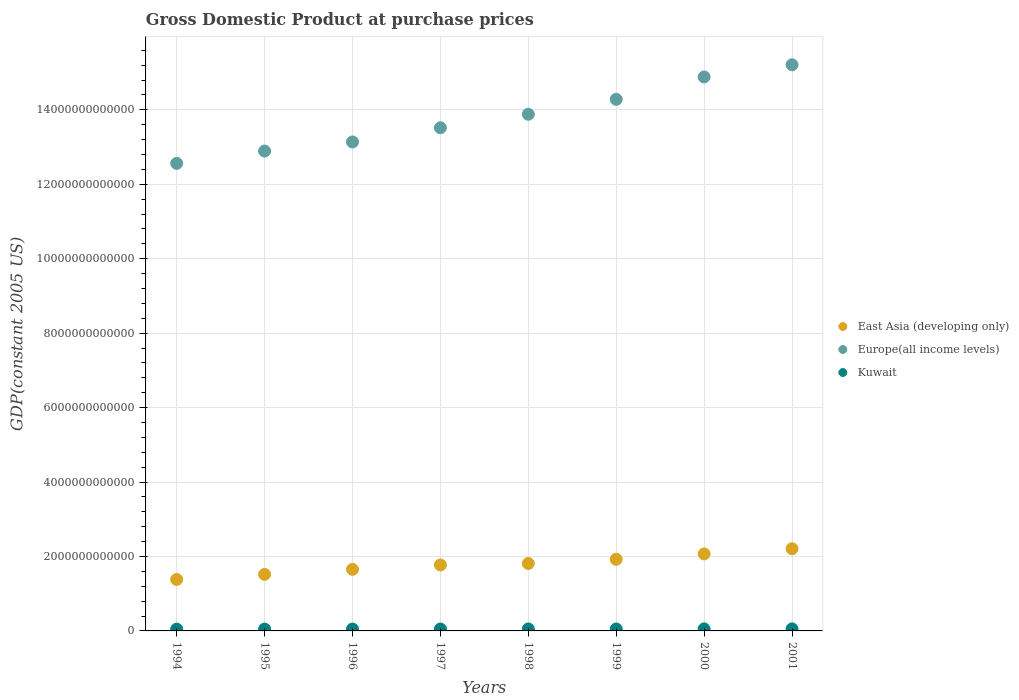What is the GDP at purchase prices in East Asia (developing only) in 2001?
Ensure brevity in your answer.  2.21e+12. Across all years, what is the maximum GDP at purchase prices in East Asia (developing only)?
Keep it short and to the point. 2.21e+12. Across all years, what is the minimum GDP at purchase prices in Kuwait?
Provide a succinct answer. 4.73e+1. In which year was the GDP at purchase prices in Kuwait maximum?
Ensure brevity in your answer.  2001. What is the total GDP at purchase prices in Kuwait in the graph?
Give a very brief answer. 4.12e+11. What is the difference between the GDP at purchase prices in East Asia (developing only) in 1994 and that in 1995?
Offer a very short reply. -1.36e+11. What is the difference between the GDP at purchase prices in East Asia (developing only) in 2000 and the GDP at purchase prices in Kuwait in 1996?
Your response must be concise. 2.02e+12. What is the average GDP at purchase prices in Kuwait per year?
Your response must be concise. 5.15e+1. In the year 1995, what is the difference between the GDP at purchase prices in Kuwait and GDP at purchase prices in Europe(all income levels)?
Offer a terse response. -1.28e+13. What is the ratio of the GDP at purchase prices in Kuwait in 1995 to that in 2001?
Offer a very short reply. 0.9. Is the GDP at purchase prices in Kuwait in 1996 less than that in 2000?
Provide a short and direct response. Yes. What is the difference between the highest and the second highest GDP at purchase prices in Europe(all income levels)?
Keep it short and to the point. 3.26e+11. What is the difference between the highest and the lowest GDP at purchase prices in Kuwait?
Ensure brevity in your answer.  7.59e+09. In how many years, is the GDP at purchase prices in Kuwait greater than the average GDP at purchase prices in Kuwait taken over all years?
Provide a succinct answer. 4. Is the sum of the GDP at purchase prices in Kuwait in 1994 and 1998 greater than the maximum GDP at purchase prices in East Asia (developing only) across all years?
Your answer should be compact. No. Is it the case that in every year, the sum of the GDP at purchase prices in Kuwait and GDP at purchase prices in East Asia (developing only)  is greater than the GDP at purchase prices in Europe(all income levels)?
Make the answer very short. No. Does the GDP at purchase prices in East Asia (developing only) monotonically increase over the years?
Provide a succinct answer. Yes. Is the GDP at purchase prices in Europe(all income levels) strictly less than the GDP at purchase prices in East Asia (developing only) over the years?
Provide a succinct answer. No. How many dotlines are there?
Your answer should be compact. 3. What is the difference between two consecutive major ticks on the Y-axis?
Make the answer very short. 2.00e+12. Are the values on the major ticks of Y-axis written in scientific E-notation?
Offer a terse response. No. Where does the legend appear in the graph?
Your answer should be compact. Center right. How many legend labels are there?
Ensure brevity in your answer.  3. How are the legend labels stacked?
Your answer should be compact. Vertical. What is the title of the graph?
Offer a very short reply. Gross Domestic Product at purchase prices. What is the label or title of the Y-axis?
Provide a short and direct response. GDP(constant 2005 US). What is the GDP(constant 2005 US) in East Asia (developing only) in 1994?
Make the answer very short. 1.38e+12. What is the GDP(constant 2005 US) in Europe(all income levels) in 1994?
Your answer should be very brief. 1.26e+13. What is the GDP(constant 2005 US) of Kuwait in 1994?
Your answer should be compact. 4.73e+1. What is the GDP(constant 2005 US) in East Asia (developing only) in 1995?
Make the answer very short. 1.52e+12. What is the GDP(constant 2005 US) in Europe(all income levels) in 1995?
Provide a short and direct response. 1.29e+13. What is the GDP(constant 2005 US) in Kuwait in 1995?
Offer a very short reply. 4.95e+1. What is the GDP(constant 2005 US) in East Asia (developing only) in 1996?
Your response must be concise. 1.65e+12. What is the GDP(constant 2005 US) in Europe(all income levels) in 1996?
Your answer should be compact. 1.31e+13. What is the GDP(constant 2005 US) of Kuwait in 1996?
Your answer should be compact. 4.98e+1. What is the GDP(constant 2005 US) of East Asia (developing only) in 1997?
Provide a succinct answer. 1.77e+12. What is the GDP(constant 2005 US) of Europe(all income levels) in 1997?
Keep it short and to the point. 1.35e+13. What is the GDP(constant 2005 US) of Kuwait in 1997?
Ensure brevity in your answer.  5.11e+1. What is the GDP(constant 2005 US) in East Asia (developing only) in 1998?
Offer a very short reply. 1.81e+12. What is the GDP(constant 2005 US) in Europe(all income levels) in 1998?
Offer a very short reply. 1.39e+13. What is the GDP(constant 2005 US) of Kuwait in 1998?
Keep it short and to the point. 5.30e+1. What is the GDP(constant 2005 US) of East Asia (developing only) in 1999?
Your response must be concise. 1.92e+12. What is the GDP(constant 2005 US) in Europe(all income levels) in 1999?
Keep it short and to the point. 1.43e+13. What is the GDP(constant 2005 US) of Kuwait in 1999?
Offer a very short reply. 5.20e+1. What is the GDP(constant 2005 US) of East Asia (developing only) in 2000?
Provide a short and direct response. 2.07e+12. What is the GDP(constant 2005 US) of Europe(all income levels) in 2000?
Provide a succinct answer. 1.49e+13. What is the GDP(constant 2005 US) in Kuwait in 2000?
Provide a short and direct response. 5.44e+1. What is the GDP(constant 2005 US) of East Asia (developing only) in 2001?
Offer a terse response. 2.21e+12. What is the GDP(constant 2005 US) in Europe(all income levels) in 2001?
Give a very brief answer. 1.52e+13. What is the GDP(constant 2005 US) of Kuwait in 2001?
Offer a very short reply. 5.48e+1. Across all years, what is the maximum GDP(constant 2005 US) in East Asia (developing only)?
Keep it short and to the point. 2.21e+12. Across all years, what is the maximum GDP(constant 2005 US) of Europe(all income levels)?
Ensure brevity in your answer.  1.52e+13. Across all years, what is the maximum GDP(constant 2005 US) of Kuwait?
Provide a succinct answer. 5.48e+1. Across all years, what is the minimum GDP(constant 2005 US) in East Asia (developing only)?
Keep it short and to the point. 1.38e+12. Across all years, what is the minimum GDP(constant 2005 US) of Europe(all income levels)?
Offer a very short reply. 1.26e+13. Across all years, what is the minimum GDP(constant 2005 US) in Kuwait?
Make the answer very short. 4.73e+1. What is the total GDP(constant 2005 US) in East Asia (developing only) in the graph?
Keep it short and to the point. 1.43e+13. What is the total GDP(constant 2005 US) in Europe(all income levels) in the graph?
Give a very brief answer. 1.10e+14. What is the total GDP(constant 2005 US) of Kuwait in the graph?
Make the answer very short. 4.12e+11. What is the difference between the GDP(constant 2005 US) of East Asia (developing only) in 1994 and that in 1995?
Make the answer very short. -1.36e+11. What is the difference between the GDP(constant 2005 US) of Europe(all income levels) in 1994 and that in 1995?
Offer a very short reply. -3.31e+11. What is the difference between the GDP(constant 2005 US) of Kuwait in 1994 and that in 1995?
Provide a short and direct response. -2.30e+09. What is the difference between the GDP(constant 2005 US) in East Asia (developing only) in 1994 and that in 1996?
Give a very brief answer. -2.72e+11. What is the difference between the GDP(constant 2005 US) of Europe(all income levels) in 1994 and that in 1996?
Ensure brevity in your answer.  -5.76e+11. What is the difference between the GDP(constant 2005 US) of Kuwait in 1994 and that in 1996?
Ensure brevity in your answer.  -2.60e+09. What is the difference between the GDP(constant 2005 US) of East Asia (developing only) in 1994 and that in 1997?
Give a very brief answer. -3.90e+11. What is the difference between the GDP(constant 2005 US) in Europe(all income levels) in 1994 and that in 1997?
Offer a very short reply. -9.57e+11. What is the difference between the GDP(constant 2005 US) in Kuwait in 1994 and that in 1997?
Your answer should be compact. -3.83e+09. What is the difference between the GDP(constant 2005 US) of East Asia (developing only) in 1994 and that in 1998?
Your response must be concise. -4.29e+11. What is the difference between the GDP(constant 2005 US) of Europe(all income levels) in 1994 and that in 1998?
Provide a succinct answer. -1.32e+12. What is the difference between the GDP(constant 2005 US) of Kuwait in 1994 and that in 1998?
Your answer should be compact. -5.70e+09. What is the difference between the GDP(constant 2005 US) in East Asia (developing only) in 1994 and that in 1999?
Provide a succinct answer. -5.42e+11. What is the difference between the GDP(constant 2005 US) in Europe(all income levels) in 1994 and that in 1999?
Make the answer very short. -1.72e+12. What is the difference between the GDP(constant 2005 US) in Kuwait in 1994 and that in 1999?
Make the answer very short. -4.75e+09. What is the difference between the GDP(constant 2005 US) in East Asia (developing only) in 1994 and that in 2000?
Provide a succinct answer. -6.87e+11. What is the difference between the GDP(constant 2005 US) of Europe(all income levels) in 1994 and that in 2000?
Offer a terse response. -2.32e+12. What is the difference between the GDP(constant 2005 US) in Kuwait in 1994 and that in 2000?
Make the answer very short. -7.19e+09. What is the difference between the GDP(constant 2005 US) in East Asia (developing only) in 1994 and that in 2001?
Provide a short and direct response. -8.25e+11. What is the difference between the GDP(constant 2005 US) in Europe(all income levels) in 1994 and that in 2001?
Offer a terse response. -2.65e+12. What is the difference between the GDP(constant 2005 US) in Kuwait in 1994 and that in 2001?
Make the answer very short. -7.59e+09. What is the difference between the GDP(constant 2005 US) of East Asia (developing only) in 1995 and that in 1996?
Your answer should be very brief. -1.36e+11. What is the difference between the GDP(constant 2005 US) of Europe(all income levels) in 1995 and that in 1996?
Make the answer very short. -2.45e+11. What is the difference between the GDP(constant 2005 US) in Kuwait in 1995 and that in 1996?
Offer a terse response. -3.00e+08. What is the difference between the GDP(constant 2005 US) in East Asia (developing only) in 1995 and that in 1997?
Ensure brevity in your answer.  -2.53e+11. What is the difference between the GDP(constant 2005 US) of Europe(all income levels) in 1995 and that in 1997?
Your answer should be very brief. -6.26e+11. What is the difference between the GDP(constant 2005 US) of Kuwait in 1995 and that in 1997?
Make the answer very short. -1.53e+09. What is the difference between the GDP(constant 2005 US) in East Asia (developing only) in 1995 and that in 1998?
Keep it short and to the point. -2.93e+11. What is the difference between the GDP(constant 2005 US) of Europe(all income levels) in 1995 and that in 1998?
Your answer should be very brief. -9.89e+11. What is the difference between the GDP(constant 2005 US) in Kuwait in 1995 and that in 1998?
Give a very brief answer. -3.40e+09. What is the difference between the GDP(constant 2005 US) of East Asia (developing only) in 1995 and that in 1999?
Your answer should be very brief. -4.06e+11. What is the difference between the GDP(constant 2005 US) in Europe(all income levels) in 1995 and that in 1999?
Make the answer very short. -1.39e+12. What is the difference between the GDP(constant 2005 US) of Kuwait in 1995 and that in 1999?
Your response must be concise. -2.46e+09. What is the difference between the GDP(constant 2005 US) in East Asia (developing only) in 1995 and that in 2000?
Provide a short and direct response. -5.50e+11. What is the difference between the GDP(constant 2005 US) in Europe(all income levels) in 1995 and that in 2000?
Your response must be concise. -1.99e+12. What is the difference between the GDP(constant 2005 US) of Kuwait in 1995 and that in 2000?
Provide a short and direct response. -4.90e+09. What is the difference between the GDP(constant 2005 US) in East Asia (developing only) in 1995 and that in 2001?
Provide a succinct answer. -6.89e+11. What is the difference between the GDP(constant 2005 US) in Europe(all income levels) in 1995 and that in 2001?
Give a very brief answer. -2.32e+12. What is the difference between the GDP(constant 2005 US) of Kuwait in 1995 and that in 2001?
Keep it short and to the point. -5.29e+09. What is the difference between the GDP(constant 2005 US) of East Asia (developing only) in 1996 and that in 1997?
Your response must be concise. -1.17e+11. What is the difference between the GDP(constant 2005 US) of Europe(all income levels) in 1996 and that in 1997?
Offer a terse response. -3.81e+11. What is the difference between the GDP(constant 2005 US) in Kuwait in 1996 and that in 1997?
Your response must be concise. -1.23e+09. What is the difference between the GDP(constant 2005 US) of East Asia (developing only) in 1996 and that in 1998?
Give a very brief answer. -1.57e+11. What is the difference between the GDP(constant 2005 US) in Europe(all income levels) in 1996 and that in 1998?
Your answer should be compact. -7.44e+11. What is the difference between the GDP(constant 2005 US) in Kuwait in 1996 and that in 1998?
Give a very brief answer. -3.10e+09. What is the difference between the GDP(constant 2005 US) of East Asia (developing only) in 1996 and that in 1999?
Make the answer very short. -2.70e+11. What is the difference between the GDP(constant 2005 US) of Europe(all income levels) in 1996 and that in 1999?
Provide a succinct answer. -1.15e+12. What is the difference between the GDP(constant 2005 US) in Kuwait in 1996 and that in 1999?
Provide a succinct answer. -2.16e+09. What is the difference between the GDP(constant 2005 US) in East Asia (developing only) in 1996 and that in 2000?
Offer a terse response. -4.14e+11. What is the difference between the GDP(constant 2005 US) of Europe(all income levels) in 1996 and that in 2000?
Your response must be concise. -1.75e+12. What is the difference between the GDP(constant 2005 US) of Kuwait in 1996 and that in 2000?
Offer a very short reply. -4.60e+09. What is the difference between the GDP(constant 2005 US) in East Asia (developing only) in 1996 and that in 2001?
Ensure brevity in your answer.  -5.53e+11. What is the difference between the GDP(constant 2005 US) in Europe(all income levels) in 1996 and that in 2001?
Offer a terse response. -2.07e+12. What is the difference between the GDP(constant 2005 US) in Kuwait in 1996 and that in 2001?
Your answer should be compact. -4.99e+09. What is the difference between the GDP(constant 2005 US) in East Asia (developing only) in 1997 and that in 1998?
Ensure brevity in your answer.  -3.97e+1. What is the difference between the GDP(constant 2005 US) of Europe(all income levels) in 1997 and that in 1998?
Give a very brief answer. -3.62e+11. What is the difference between the GDP(constant 2005 US) of Kuwait in 1997 and that in 1998?
Offer a terse response. -1.87e+09. What is the difference between the GDP(constant 2005 US) in East Asia (developing only) in 1997 and that in 1999?
Keep it short and to the point. -1.53e+11. What is the difference between the GDP(constant 2005 US) in Europe(all income levels) in 1997 and that in 1999?
Your response must be concise. -7.64e+11. What is the difference between the GDP(constant 2005 US) in Kuwait in 1997 and that in 1999?
Give a very brief answer. -9.23e+08. What is the difference between the GDP(constant 2005 US) of East Asia (developing only) in 1997 and that in 2000?
Give a very brief answer. -2.97e+11. What is the difference between the GDP(constant 2005 US) of Europe(all income levels) in 1997 and that in 2000?
Ensure brevity in your answer.  -1.37e+12. What is the difference between the GDP(constant 2005 US) of Kuwait in 1997 and that in 2000?
Provide a short and direct response. -3.36e+09. What is the difference between the GDP(constant 2005 US) in East Asia (developing only) in 1997 and that in 2001?
Keep it short and to the point. -4.36e+11. What is the difference between the GDP(constant 2005 US) in Europe(all income levels) in 1997 and that in 2001?
Keep it short and to the point. -1.69e+12. What is the difference between the GDP(constant 2005 US) of Kuwait in 1997 and that in 2001?
Your response must be concise. -3.76e+09. What is the difference between the GDP(constant 2005 US) in East Asia (developing only) in 1998 and that in 1999?
Offer a terse response. -1.13e+11. What is the difference between the GDP(constant 2005 US) in Europe(all income levels) in 1998 and that in 1999?
Offer a terse response. -4.02e+11. What is the difference between the GDP(constant 2005 US) in Kuwait in 1998 and that in 1999?
Your answer should be very brief. 9.47e+08. What is the difference between the GDP(constant 2005 US) of East Asia (developing only) in 1998 and that in 2000?
Offer a terse response. -2.57e+11. What is the difference between the GDP(constant 2005 US) of Europe(all income levels) in 1998 and that in 2000?
Your response must be concise. -1.00e+12. What is the difference between the GDP(constant 2005 US) of Kuwait in 1998 and that in 2000?
Provide a succinct answer. -1.49e+09. What is the difference between the GDP(constant 2005 US) in East Asia (developing only) in 1998 and that in 2001?
Your response must be concise. -3.96e+11. What is the difference between the GDP(constant 2005 US) in Europe(all income levels) in 1998 and that in 2001?
Offer a terse response. -1.33e+12. What is the difference between the GDP(constant 2005 US) of Kuwait in 1998 and that in 2001?
Provide a succinct answer. -1.89e+09. What is the difference between the GDP(constant 2005 US) of East Asia (developing only) in 1999 and that in 2000?
Your answer should be very brief. -1.45e+11. What is the difference between the GDP(constant 2005 US) of Europe(all income levels) in 1999 and that in 2000?
Ensure brevity in your answer.  -6.01e+11. What is the difference between the GDP(constant 2005 US) in Kuwait in 1999 and that in 2000?
Provide a short and direct response. -2.44e+09. What is the difference between the GDP(constant 2005 US) of East Asia (developing only) in 1999 and that in 2001?
Offer a terse response. -2.83e+11. What is the difference between the GDP(constant 2005 US) in Europe(all income levels) in 1999 and that in 2001?
Provide a succinct answer. -9.27e+11. What is the difference between the GDP(constant 2005 US) in Kuwait in 1999 and that in 2001?
Your answer should be compact. -2.84e+09. What is the difference between the GDP(constant 2005 US) in East Asia (developing only) in 2000 and that in 2001?
Give a very brief answer. -1.39e+11. What is the difference between the GDP(constant 2005 US) of Europe(all income levels) in 2000 and that in 2001?
Your response must be concise. -3.26e+11. What is the difference between the GDP(constant 2005 US) in Kuwait in 2000 and that in 2001?
Your answer should be very brief. -3.97e+08. What is the difference between the GDP(constant 2005 US) in East Asia (developing only) in 1994 and the GDP(constant 2005 US) in Europe(all income levels) in 1995?
Provide a short and direct response. -1.15e+13. What is the difference between the GDP(constant 2005 US) in East Asia (developing only) in 1994 and the GDP(constant 2005 US) in Kuwait in 1995?
Make the answer very short. 1.33e+12. What is the difference between the GDP(constant 2005 US) of Europe(all income levels) in 1994 and the GDP(constant 2005 US) of Kuwait in 1995?
Your response must be concise. 1.25e+13. What is the difference between the GDP(constant 2005 US) of East Asia (developing only) in 1994 and the GDP(constant 2005 US) of Europe(all income levels) in 1996?
Make the answer very short. -1.18e+13. What is the difference between the GDP(constant 2005 US) in East Asia (developing only) in 1994 and the GDP(constant 2005 US) in Kuwait in 1996?
Provide a succinct answer. 1.33e+12. What is the difference between the GDP(constant 2005 US) of Europe(all income levels) in 1994 and the GDP(constant 2005 US) of Kuwait in 1996?
Your answer should be compact. 1.25e+13. What is the difference between the GDP(constant 2005 US) in East Asia (developing only) in 1994 and the GDP(constant 2005 US) in Europe(all income levels) in 1997?
Your answer should be compact. -1.21e+13. What is the difference between the GDP(constant 2005 US) of East Asia (developing only) in 1994 and the GDP(constant 2005 US) of Kuwait in 1997?
Offer a terse response. 1.33e+12. What is the difference between the GDP(constant 2005 US) of Europe(all income levels) in 1994 and the GDP(constant 2005 US) of Kuwait in 1997?
Offer a terse response. 1.25e+13. What is the difference between the GDP(constant 2005 US) of East Asia (developing only) in 1994 and the GDP(constant 2005 US) of Europe(all income levels) in 1998?
Ensure brevity in your answer.  -1.25e+13. What is the difference between the GDP(constant 2005 US) in East Asia (developing only) in 1994 and the GDP(constant 2005 US) in Kuwait in 1998?
Provide a short and direct response. 1.33e+12. What is the difference between the GDP(constant 2005 US) in Europe(all income levels) in 1994 and the GDP(constant 2005 US) in Kuwait in 1998?
Offer a terse response. 1.25e+13. What is the difference between the GDP(constant 2005 US) of East Asia (developing only) in 1994 and the GDP(constant 2005 US) of Europe(all income levels) in 1999?
Keep it short and to the point. -1.29e+13. What is the difference between the GDP(constant 2005 US) in East Asia (developing only) in 1994 and the GDP(constant 2005 US) in Kuwait in 1999?
Offer a terse response. 1.33e+12. What is the difference between the GDP(constant 2005 US) of Europe(all income levels) in 1994 and the GDP(constant 2005 US) of Kuwait in 1999?
Provide a succinct answer. 1.25e+13. What is the difference between the GDP(constant 2005 US) of East Asia (developing only) in 1994 and the GDP(constant 2005 US) of Europe(all income levels) in 2000?
Provide a succinct answer. -1.35e+13. What is the difference between the GDP(constant 2005 US) of East Asia (developing only) in 1994 and the GDP(constant 2005 US) of Kuwait in 2000?
Provide a succinct answer. 1.33e+12. What is the difference between the GDP(constant 2005 US) in Europe(all income levels) in 1994 and the GDP(constant 2005 US) in Kuwait in 2000?
Provide a succinct answer. 1.25e+13. What is the difference between the GDP(constant 2005 US) of East Asia (developing only) in 1994 and the GDP(constant 2005 US) of Europe(all income levels) in 2001?
Your response must be concise. -1.38e+13. What is the difference between the GDP(constant 2005 US) of East Asia (developing only) in 1994 and the GDP(constant 2005 US) of Kuwait in 2001?
Give a very brief answer. 1.33e+12. What is the difference between the GDP(constant 2005 US) of Europe(all income levels) in 1994 and the GDP(constant 2005 US) of Kuwait in 2001?
Your answer should be compact. 1.25e+13. What is the difference between the GDP(constant 2005 US) in East Asia (developing only) in 1995 and the GDP(constant 2005 US) in Europe(all income levels) in 1996?
Your answer should be very brief. -1.16e+13. What is the difference between the GDP(constant 2005 US) in East Asia (developing only) in 1995 and the GDP(constant 2005 US) in Kuwait in 1996?
Provide a short and direct response. 1.47e+12. What is the difference between the GDP(constant 2005 US) of Europe(all income levels) in 1995 and the GDP(constant 2005 US) of Kuwait in 1996?
Offer a very short reply. 1.28e+13. What is the difference between the GDP(constant 2005 US) in East Asia (developing only) in 1995 and the GDP(constant 2005 US) in Europe(all income levels) in 1997?
Your answer should be very brief. -1.20e+13. What is the difference between the GDP(constant 2005 US) of East Asia (developing only) in 1995 and the GDP(constant 2005 US) of Kuwait in 1997?
Offer a terse response. 1.47e+12. What is the difference between the GDP(constant 2005 US) in Europe(all income levels) in 1995 and the GDP(constant 2005 US) in Kuwait in 1997?
Provide a succinct answer. 1.28e+13. What is the difference between the GDP(constant 2005 US) of East Asia (developing only) in 1995 and the GDP(constant 2005 US) of Europe(all income levels) in 1998?
Provide a succinct answer. -1.24e+13. What is the difference between the GDP(constant 2005 US) of East Asia (developing only) in 1995 and the GDP(constant 2005 US) of Kuwait in 1998?
Your response must be concise. 1.47e+12. What is the difference between the GDP(constant 2005 US) in Europe(all income levels) in 1995 and the GDP(constant 2005 US) in Kuwait in 1998?
Keep it short and to the point. 1.28e+13. What is the difference between the GDP(constant 2005 US) of East Asia (developing only) in 1995 and the GDP(constant 2005 US) of Europe(all income levels) in 1999?
Make the answer very short. -1.28e+13. What is the difference between the GDP(constant 2005 US) in East Asia (developing only) in 1995 and the GDP(constant 2005 US) in Kuwait in 1999?
Provide a short and direct response. 1.47e+12. What is the difference between the GDP(constant 2005 US) of Europe(all income levels) in 1995 and the GDP(constant 2005 US) of Kuwait in 1999?
Your answer should be compact. 1.28e+13. What is the difference between the GDP(constant 2005 US) of East Asia (developing only) in 1995 and the GDP(constant 2005 US) of Europe(all income levels) in 2000?
Offer a terse response. -1.34e+13. What is the difference between the GDP(constant 2005 US) in East Asia (developing only) in 1995 and the GDP(constant 2005 US) in Kuwait in 2000?
Ensure brevity in your answer.  1.46e+12. What is the difference between the GDP(constant 2005 US) in Europe(all income levels) in 1995 and the GDP(constant 2005 US) in Kuwait in 2000?
Make the answer very short. 1.28e+13. What is the difference between the GDP(constant 2005 US) in East Asia (developing only) in 1995 and the GDP(constant 2005 US) in Europe(all income levels) in 2001?
Your response must be concise. -1.37e+13. What is the difference between the GDP(constant 2005 US) of East Asia (developing only) in 1995 and the GDP(constant 2005 US) of Kuwait in 2001?
Give a very brief answer. 1.46e+12. What is the difference between the GDP(constant 2005 US) in Europe(all income levels) in 1995 and the GDP(constant 2005 US) in Kuwait in 2001?
Your response must be concise. 1.28e+13. What is the difference between the GDP(constant 2005 US) of East Asia (developing only) in 1996 and the GDP(constant 2005 US) of Europe(all income levels) in 1997?
Make the answer very short. -1.19e+13. What is the difference between the GDP(constant 2005 US) of East Asia (developing only) in 1996 and the GDP(constant 2005 US) of Kuwait in 1997?
Provide a short and direct response. 1.60e+12. What is the difference between the GDP(constant 2005 US) in Europe(all income levels) in 1996 and the GDP(constant 2005 US) in Kuwait in 1997?
Keep it short and to the point. 1.31e+13. What is the difference between the GDP(constant 2005 US) of East Asia (developing only) in 1996 and the GDP(constant 2005 US) of Europe(all income levels) in 1998?
Your answer should be compact. -1.22e+13. What is the difference between the GDP(constant 2005 US) of East Asia (developing only) in 1996 and the GDP(constant 2005 US) of Kuwait in 1998?
Keep it short and to the point. 1.60e+12. What is the difference between the GDP(constant 2005 US) of Europe(all income levels) in 1996 and the GDP(constant 2005 US) of Kuwait in 1998?
Your response must be concise. 1.31e+13. What is the difference between the GDP(constant 2005 US) of East Asia (developing only) in 1996 and the GDP(constant 2005 US) of Europe(all income levels) in 1999?
Your answer should be very brief. -1.26e+13. What is the difference between the GDP(constant 2005 US) of East Asia (developing only) in 1996 and the GDP(constant 2005 US) of Kuwait in 1999?
Provide a succinct answer. 1.60e+12. What is the difference between the GDP(constant 2005 US) in Europe(all income levels) in 1996 and the GDP(constant 2005 US) in Kuwait in 1999?
Your answer should be very brief. 1.31e+13. What is the difference between the GDP(constant 2005 US) in East Asia (developing only) in 1996 and the GDP(constant 2005 US) in Europe(all income levels) in 2000?
Your answer should be compact. -1.32e+13. What is the difference between the GDP(constant 2005 US) in East Asia (developing only) in 1996 and the GDP(constant 2005 US) in Kuwait in 2000?
Offer a terse response. 1.60e+12. What is the difference between the GDP(constant 2005 US) of Europe(all income levels) in 1996 and the GDP(constant 2005 US) of Kuwait in 2000?
Offer a very short reply. 1.31e+13. What is the difference between the GDP(constant 2005 US) in East Asia (developing only) in 1996 and the GDP(constant 2005 US) in Europe(all income levels) in 2001?
Offer a very short reply. -1.36e+13. What is the difference between the GDP(constant 2005 US) of East Asia (developing only) in 1996 and the GDP(constant 2005 US) of Kuwait in 2001?
Provide a short and direct response. 1.60e+12. What is the difference between the GDP(constant 2005 US) in Europe(all income levels) in 1996 and the GDP(constant 2005 US) in Kuwait in 2001?
Provide a succinct answer. 1.31e+13. What is the difference between the GDP(constant 2005 US) in East Asia (developing only) in 1997 and the GDP(constant 2005 US) in Europe(all income levels) in 1998?
Offer a terse response. -1.21e+13. What is the difference between the GDP(constant 2005 US) in East Asia (developing only) in 1997 and the GDP(constant 2005 US) in Kuwait in 1998?
Keep it short and to the point. 1.72e+12. What is the difference between the GDP(constant 2005 US) of Europe(all income levels) in 1997 and the GDP(constant 2005 US) of Kuwait in 1998?
Give a very brief answer. 1.35e+13. What is the difference between the GDP(constant 2005 US) in East Asia (developing only) in 1997 and the GDP(constant 2005 US) in Europe(all income levels) in 1999?
Your response must be concise. -1.25e+13. What is the difference between the GDP(constant 2005 US) of East Asia (developing only) in 1997 and the GDP(constant 2005 US) of Kuwait in 1999?
Provide a short and direct response. 1.72e+12. What is the difference between the GDP(constant 2005 US) in Europe(all income levels) in 1997 and the GDP(constant 2005 US) in Kuwait in 1999?
Provide a short and direct response. 1.35e+13. What is the difference between the GDP(constant 2005 US) of East Asia (developing only) in 1997 and the GDP(constant 2005 US) of Europe(all income levels) in 2000?
Your answer should be compact. -1.31e+13. What is the difference between the GDP(constant 2005 US) in East Asia (developing only) in 1997 and the GDP(constant 2005 US) in Kuwait in 2000?
Offer a very short reply. 1.72e+12. What is the difference between the GDP(constant 2005 US) of Europe(all income levels) in 1997 and the GDP(constant 2005 US) of Kuwait in 2000?
Keep it short and to the point. 1.35e+13. What is the difference between the GDP(constant 2005 US) of East Asia (developing only) in 1997 and the GDP(constant 2005 US) of Europe(all income levels) in 2001?
Offer a very short reply. -1.34e+13. What is the difference between the GDP(constant 2005 US) in East Asia (developing only) in 1997 and the GDP(constant 2005 US) in Kuwait in 2001?
Your answer should be very brief. 1.72e+12. What is the difference between the GDP(constant 2005 US) in Europe(all income levels) in 1997 and the GDP(constant 2005 US) in Kuwait in 2001?
Offer a terse response. 1.35e+13. What is the difference between the GDP(constant 2005 US) of East Asia (developing only) in 1998 and the GDP(constant 2005 US) of Europe(all income levels) in 1999?
Keep it short and to the point. -1.25e+13. What is the difference between the GDP(constant 2005 US) in East Asia (developing only) in 1998 and the GDP(constant 2005 US) in Kuwait in 1999?
Your response must be concise. 1.76e+12. What is the difference between the GDP(constant 2005 US) in Europe(all income levels) in 1998 and the GDP(constant 2005 US) in Kuwait in 1999?
Your answer should be very brief. 1.38e+13. What is the difference between the GDP(constant 2005 US) of East Asia (developing only) in 1998 and the GDP(constant 2005 US) of Europe(all income levels) in 2000?
Ensure brevity in your answer.  -1.31e+13. What is the difference between the GDP(constant 2005 US) in East Asia (developing only) in 1998 and the GDP(constant 2005 US) in Kuwait in 2000?
Offer a terse response. 1.76e+12. What is the difference between the GDP(constant 2005 US) in Europe(all income levels) in 1998 and the GDP(constant 2005 US) in Kuwait in 2000?
Ensure brevity in your answer.  1.38e+13. What is the difference between the GDP(constant 2005 US) of East Asia (developing only) in 1998 and the GDP(constant 2005 US) of Europe(all income levels) in 2001?
Keep it short and to the point. -1.34e+13. What is the difference between the GDP(constant 2005 US) of East Asia (developing only) in 1998 and the GDP(constant 2005 US) of Kuwait in 2001?
Give a very brief answer. 1.76e+12. What is the difference between the GDP(constant 2005 US) in Europe(all income levels) in 1998 and the GDP(constant 2005 US) in Kuwait in 2001?
Your response must be concise. 1.38e+13. What is the difference between the GDP(constant 2005 US) in East Asia (developing only) in 1999 and the GDP(constant 2005 US) in Europe(all income levels) in 2000?
Your answer should be very brief. -1.30e+13. What is the difference between the GDP(constant 2005 US) in East Asia (developing only) in 1999 and the GDP(constant 2005 US) in Kuwait in 2000?
Your response must be concise. 1.87e+12. What is the difference between the GDP(constant 2005 US) in Europe(all income levels) in 1999 and the GDP(constant 2005 US) in Kuwait in 2000?
Offer a terse response. 1.42e+13. What is the difference between the GDP(constant 2005 US) of East Asia (developing only) in 1999 and the GDP(constant 2005 US) of Europe(all income levels) in 2001?
Your response must be concise. -1.33e+13. What is the difference between the GDP(constant 2005 US) in East Asia (developing only) in 1999 and the GDP(constant 2005 US) in Kuwait in 2001?
Offer a terse response. 1.87e+12. What is the difference between the GDP(constant 2005 US) in Europe(all income levels) in 1999 and the GDP(constant 2005 US) in Kuwait in 2001?
Give a very brief answer. 1.42e+13. What is the difference between the GDP(constant 2005 US) in East Asia (developing only) in 2000 and the GDP(constant 2005 US) in Europe(all income levels) in 2001?
Your answer should be very brief. -1.31e+13. What is the difference between the GDP(constant 2005 US) in East Asia (developing only) in 2000 and the GDP(constant 2005 US) in Kuwait in 2001?
Provide a short and direct response. 2.01e+12. What is the difference between the GDP(constant 2005 US) of Europe(all income levels) in 2000 and the GDP(constant 2005 US) of Kuwait in 2001?
Offer a very short reply. 1.48e+13. What is the average GDP(constant 2005 US) of East Asia (developing only) per year?
Offer a very short reply. 1.79e+12. What is the average GDP(constant 2005 US) of Europe(all income levels) per year?
Offer a very short reply. 1.38e+13. What is the average GDP(constant 2005 US) of Kuwait per year?
Ensure brevity in your answer.  5.15e+1. In the year 1994, what is the difference between the GDP(constant 2005 US) in East Asia (developing only) and GDP(constant 2005 US) in Europe(all income levels)?
Provide a succinct answer. -1.12e+13. In the year 1994, what is the difference between the GDP(constant 2005 US) in East Asia (developing only) and GDP(constant 2005 US) in Kuwait?
Provide a succinct answer. 1.34e+12. In the year 1994, what is the difference between the GDP(constant 2005 US) of Europe(all income levels) and GDP(constant 2005 US) of Kuwait?
Provide a short and direct response. 1.25e+13. In the year 1995, what is the difference between the GDP(constant 2005 US) in East Asia (developing only) and GDP(constant 2005 US) in Europe(all income levels)?
Your answer should be very brief. -1.14e+13. In the year 1995, what is the difference between the GDP(constant 2005 US) in East Asia (developing only) and GDP(constant 2005 US) in Kuwait?
Keep it short and to the point. 1.47e+12. In the year 1995, what is the difference between the GDP(constant 2005 US) in Europe(all income levels) and GDP(constant 2005 US) in Kuwait?
Provide a short and direct response. 1.28e+13. In the year 1996, what is the difference between the GDP(constant 2005 US) in East Asia (developing only) and GDP(constant 2005 US) in Europe(all income levels)?
Keep it short and to the point. -1.15e+13. In the year 1996, what is the difference between the GDP(constant 2005 US) in East Asia (developing only) and GDP(constant 2005 US) in Kuwait?
Your response must be concise. 1.60e+12. In the year 1996, what is the difference between the GDP(constant 2005 US) of Europe(all income levels) and GDP(constant 2005 US) of Kuwait?
Ensure brevity in your answer.  1.31e+13. In the year 1997, what is the difference between the GDP(constant 2005 US) in East Asia (developing only) and GDP(constant 2005 US) in Europe(all income levels)?
Your answer should be compact. -1.17e+13. In the year 1997, what is the difference between the GDP(constant 2005 US) in East Asia (developing only) and GDP(constant 2005 US) in Kuwait?
Make the answer very short. 1.72e+12. In the year 1997, what is the difference between the GDP(constant 2005 US) in Europe(all income levels) and GDP(constant 2005 US) in Kuwait?
Ensure brevity in your answer.  1.35e+13. In the year 1998, what is the difference between the GDP(constant 2005 US) in East Asia (developing only) and GDP(constant 2005 US) in Europe(all income levels)?
Make the answer very short. -1.21e+13. In the year 1998, what is the difference between the GDP(constant 2005 US) in East Asia (developing only) and GDP(constant 2005 US) in Kuwait?
Provide a short and direct response. 1.76e+12. In the year 1998, what is the difference between the GDP(constant 2005 US) of Europe(all income levels) and GDP(constant 2005 US) of Kuwait?
Ensure brevity in your answer.  1.38e+13. In the year 1999, what is the difference between the GDP(constant 2005 US) of East Asia (developing only) and GDP(constant 2005 US) of Europe(all income levels)?
Your answer should be compact. -1.24e+13. In the year 1999, what is the difference between the GDP(constant 2005 US) of East Asia (developing only) and GDP(constant 2005 US) of Kuwait?
Keep it short and to the point. 1.87e+12. In the year 1999, what is the difference between the GDP(constant 2005 US) in Europe(all income levels) and GDP(constant 2005 US) in Kuwait?
Make the answer very short. 1.42e+13. In the year 2000, what is the difference between the GDP(constant 2005 US) in East Asia (developing only) and GDP(constant 2005 US) in Europe(all income levels)?
Your answer should be very brief. -1.28e+13. In the year 2000, what is the difference between the GDP(constant 2005 US) of East Asia (developing only) and GDP(constant 2005 US) of Kuwait?
Offer a very short reply. 2.01e+12. In the year 2000, what is the difference between the GDP(constant 2005 US) of Europe(all income levels) and GDP(constant 2005 US) of Kuwait?
Make the answer very short. 1.48e+13. In the year 2001, what is the difference between the GDP(constant 2005 US) in East Asia (developing only) and GDP(constant 2005 US) in Europe(all income levels)?
Your response must be concise. -1.30e+13. In the year 2001, what is the difference between the GDP(constant 2005 US) of East Asia (developing only) and GDP(constant 2005 US) of Kuwait?
Your response must be concise. 2.15e+12. In the year 2001, what is the difference between the GDP(constant 2005 US) in Europe(all income levels) and GDP(constant 2005 US) in Kuwait?
Your answer should be very brief. 1.52e+13. What is the ratio of the GDP(constant 2005 US) in East Asia (developing only) in 1994 to that in 1995?
Offer a terse response. 0.91. What is the ratio of the GDP(constant 2005 US) in Europe(all income levels) in 1994 to that in 1995?
Give a very brief answer. 0.97. What is the ratio of the GDP(constant 2005 US) of Kuwait in 1994 to that in 1995?
Offer a terse response. 0.95. What is the ratio of the GDP(constant 2005 US) in East Asia (developing only) in 1994 to that in 1996?
Make the answer very short. 0.84. What is the ratio of the GDP(constant 2005 US) of Europe(all income levels) in 1994 to that in 1996?
Your response must be concise. 0.96. What is the ratio of the GDP(constant 2005 US) of Kuwait in 1994 to that in 1996?
Your answer should be very brief. 0.95. What is the ratio of the GDP(constant 2005 US) of East Asia (developing only) in 1994 to that in 1997?
Offer a terse response. 0.78. What is the ratio of the GDP(constant 2005 US) of Europe(all income levels) in 1994 to that in 1997?
Your response must be concise. 0.93. What is the ratio of the GDP(constant 2005 US) in Kuwait in 1994 to that in 1997?
Your response must be concise. 0.93. What is the ratio of the GDP(constant 2005 US) in East Asia (developing only) in 1994 to that in 1998?
Give a very brief answer. 0.76. What is the ratio of the GDP(constant 2005 US) in Europe(all income levels) in 1994 to that in 1998?
Provide a succinct answer. 0.9. What is the ratio of the GDP(constant 2005 US) in Kuwait in 1994 to that in 1998?
Your answer should be compact. 0.89. What is the ratio of the GDP(constant 2005 US) of East Asia (developing only) in 1994 to that in 1999?
Keep it short and to the point. 0.72. What is the ratio of the GDP(constant 2005 US) of Europe(all income levels) in 1994 to that in 1999?
Give a very brief answer. 0.88. What is the ratio of the GDP(constant 2005 US) in Kuwait in 1994 to that in 1999?
Keep it short and to the point. 0.91. What is the ratio of the GDP(constant 2005 US) in East Asia (developing only) in 1994 to that in 2000?
Give a very brief answer. 0.67. What is the ratio of the GDP(constant 2005 US) in Europe(all income levels) in 1994 to that in 2000?
Offer a very short reply. 0.84. What is the ratio of the GDP(constant 2005 US) of Kuwait in 1994 to that in 2000?
Your answer should be very brief. 0.87. What is the ratio of the GDP(constant 2005 US) in East Asia (developing only) in 1994 to that in 2001?
Provide a succinct answer. 0.63. What is the ratio of the GDP(constant 2005 US) of Europe(all income levels) in 1994 to that in 2001?
Keep it short and to the point. 0.83. What is the ratio of the GDP(constant 2005 US) in Kuwait in 1994 to that in 2001?
Offer a terse response. 0.86. What is the ratio of the GDP(constant 2005 US) in East Asia (developing only) in 1995 to that in 1996?
Offer a terse response. 0.92. What is the ratio of the GDP(constant 2005 US) in Europe(all income levels) in 1995 to that in 1996?
Make the answer very short. 0.98. What is the ratio of the GDP(constant 2005 US) of Kuwait in 1995 to that in 1996?
Your answer should be very brief. 0.99. What is the ratio of the GDP(constant 2005 US) in East Asia (developing only) in 1995 to that in 1997?
Offer a terse response. 0.86. What is the ratio of the GDP(constant 2005 US) in Europe(all income levels) in 1995 to that in 1997?
Provide a short and direct response. 0.95. What is the ratio of the GDP(constant 2005 US) in East Asia (developing only) in 1995 to that in 1998?
Provide a succinct answer. 0.84. What is the ratio of the GDP(constant 2005 US) in Europe(all income levels) in 1995 to that in 1998?
Give a very brief answer. 0.93. What is the ratio of the GDP(constant 2005 US) in Kuwait in 1995 to that in 1998?
Provide a succinct answer. 0.94. What is the ratio of the GDP(constant 2005 US) in East Asia (developing only) in 1995 to that in 1999?
Make the answer very short. 0.79. What is the ratio of the GDP(constant 2005 US) in Europe(all income levels) in 1995 to that in 1999?
Your answer should be compact. 0.9. What is the ratio of the GDP(constant 2005 US) of Kuwait in 1995 to that in 1999?
Provide a succinct answer. 0.95. What is the ratio of the GDP(constant 2005 US) in East Asia (developing only) in 1995 to that in 2000?
Keep it short and to the point. 0.73. What is the ratio of the GDP(constant 2005 US) in Europe(all income levels) in 1995 to that in 2000?
Your answer should be compact. 0.87. What is the ratio of the GDP(constant 2005 US) in Kuwait in 1995 to that in 2000?
Your answer should be compact. 0.91. What is the ratio of the GDP(constant 2005 US) of East Asia (developing only) in 1995 to that in 2001?
Offer a very short reply. 0.69. What is the ratio of the GDP(constant 2005 US) of Europe(all income levels) in 1995 to that in 2001?
Give a very brief answer. 0.85. What is the ratio of the GDP(constant 2005 US) in Kuwait in 1995 to that in 2001?
Offer a very short reply. 0.9. What is the ratio of the GDP(constant 2005 US) of East Asia (developing only) in 1996 to that in 1997?
Your answer should be compact. 0.93. What is the ratio of the GDP(constant 2005 US) of Europe(all income levels) in 1996 to that in 1997?
Your response must be concise. 0.97. What is the ratio of the GDP(constant 2005 US) in Kuwait in 1996 to that in 1997?
Keep it short and to the point. 0.98. What is the ratio of the GDP(constant 2005 US) in East Asia (developing only) in 1996 to that in 1998?
Provide a succinct answer. 0.91. What is the ratio of the GDP(constant 2005 US) of Europe(all income levels) in 1996 to that in 1998?
Provide a succinct answer. 0.95. What is the ratio of the GDP(constant 2005 US) in Kuwait in 1996 to that in 1998?
Ensure brevity in your answer.  0.94. What is the ratio of the GDP(constant 2005 US) in East Asia (developing only) in 1996 to that in 1999?
Offer a terse response. 0.86. What is the ratio of the GDP(constant 2005 US) of Europe(all income levels) in 1996 to that in 1999?
Keep it short and to the point. 0.92. What is the ratio of the GDP(constant 2005 US) of Kuwait in 1996 to that in 1999?
Your response must be concise. 0.96. What is the ratio of the GDP(constant 2005 US) of East Asia (developing only) in 1996 to that in 2000?
Ensure brevity in your answer.  0.8. What is the ratio of the GDP(constant 2005 US) in Europe(all income levels) in 1996 to that in 2000?
Provide a short and direct response. 0.88. What is the ratio of the GDP(constant 2005 US) in Kuwait in 1996 to that in 2000?
Your answer should be very brief. 0.92. What is the ratio of the GDP(constant 2005 US) in East Asia (developing only) in 1996 to that in 2001?
Your response must be concise. 0.75. What is the ratio of the GDP(constant 2005 US) of Europe(all income levels) in 1996 to that in 2001?
Offer a terse response. 0.86. What is the ratio of the GDP(constant 2005 US) of Kuwait in 1996 to that in 2001?
Your response must be concise. 0.91. What is the ratio of the GDP(constant 2005 US) in East Asia (developing only) in 1997 to that in 1998?
Your answer should be compact. 0.98. What is the ratio of the GDP(constant 2005 US) of Europe(all income levels) in 1997 to that in 1998?
Your answer should be very brief. 0.97. What is the ratio of the GDP(constant 2005 US) in Kuwait in 1997 to that in 1998?
Your answer should be very brief. 0.96. What is the ratio of the GDP(constant 2005 US) in East Asia (developing only) in 1997 to that in 1999?
Provide a short and direct response. 0.92. What is the ratio of the GDP(constant 2005 US) in Europe(all income levels) in 1997 to that in 1999?
Offer a terse response. 0.95. What is the ratio of the GDP(constant 2005 US) of Kuwait in 1997 to that in 1999?
Give a very brief answer. 0.98. What is the ratio of the GDP(constant 2005 US) in East Asia (developing only) in 1997 to that in 2000?
Offer a very short reply. 0.86. What is the ratio of the GDP(constant 2005 US) in Europe(all income levels) in 1997 to that in 2000?
Give a very brief answer. 0.91. What is the ratio of the GDP(constant 2005 US) of Kuwait in 1997 to that in 2000?
Ensure brevity in your answer.  0.94. What is the ratio of the GDP(constant 2005 US) in East Asia (developing only) in 1997 to that in 2001?
Keep it short and to the point. 0.8. What is the ratio of the GDP(constant 2005 US) of Europe(all income levels) in 1997 to that in 2001?
Offer a terse response. 0.89. What is the ratio of the GDP(constant 2005 US) of Kuwait in 1997 to that in 2001?
Provide a succinct answer. 0.93. What is the ratio of the GDP(constant 2005 US) in East Asia (developing only) in 1998 to that in 1999?
Provide a short and direct response. 0.94. What is the ratio of the GDP(constant 2005 US) of Europe(all income levels) in 1998 to that in 1999?
Offer a terse response. 0.97. What is the ratio of the GDP(constant 2005 US) in Kuwait in 1998 to that in 1999?
Your answer should be compact. 1.02. What is the ratio of the GDP(constant 2005 US) in East Asia (developing only) in 1998 to that in 2000?
Keep it short and to the point. 0.88. What is the ratio of the GDP(constant 2005 US) in Europe(all income levels) in 1998 to that in 2000?
Your answer should be compact. 0.93. What is the ratio of the GDP(constant 2005 US) of Kuwait in 1998 to that in 2000?
Your answer should be compact. 0.97. What is the ratio of the GDP(constant 2005 US) of East Asia (developing only) in 1998 to that in 2001?
Your answer should be very brief. 0.82. What is the ratio of the GDP(constant 2005 US) of Europe(all income levels) in 1998 to that in 2001?
Offer a terse response. 0.91. What is the ratio of the GDP(constant 2005 US) of Kuwait in 1998 to that in 2001?
Offer a very short reply. 0.97. What is the ratio of the GDP(constant 2005 US) in East Asia (developing only) in 1999 to that in 2000?
Keep it short and to the point. 0.93. What is the ratio of the GDP(constant 2005 US) of Europe(all income levels) in 1999 to that in 2000?
Your answer should be compact. 0.96. What is the ratio of the GDP(constant 2005 US) in Kuwait in 1999 to that in 2000?
Keep it short and to the point. 0.96. What is the ratio of the GDP(constant 2005 US) of East Asia (developing only) in 1999 to that in 2001?
Provide a succinct answer. 0.87. What is the ratio of the GDP(constant 2005 US) in Europe(all income levels) in 1999 to that in 2001?
Ensure brevity in your answer.  0.94. What is the ratio of the GDP(constant 2005 US) of Kuwait in 1999 to that in 2001?
Your response must be concise. 0.95. What is the ratio of the GDP(constant 2005 US) of East Asia (developing only) in 2000 to that in 2001?
Keep it short and to the point. 0.94. What is the ratio of the GDP(constant 2005 US) of Europe(all income levels) in 2000 to that in 2001?
Offer a very short reply. 0.98. What is the ratio of the GDP(constant 2005 US) of Kuwait in 2000 to that in 2001?
Ensure brevity in your answer.  0.99. What is the difference between the highest and the second highest GDP(constant 2005 US) of East Asia (developing only)?
Keep it short and to the point. 1.39e+11. What is the difference between the highest and the second highest GDP(constant 2005 US) in Europe(all income levels)?
Provide a succinct answer. 3.26e+11. What is the difference between the highest and the second highest GDP(constant 2005 US) in Kuwait?
Offer a terse response. 3.97e+08. What is the difference between the highest and the lowest GDP(constant 2005 US) of East Asia (developing only)?
Provide a succinct answer. 8.25e+11. What is the difference between the highest and the lowest GDP(constant 2005 US) of Europe(all income levels)?
Ensure brevity in your answer.  2.65e+12. What is the difference between the highest and the lowest GDP(constant 2005 US) of Kuwait?
Keep it short and to the point. 7.59e+09. 